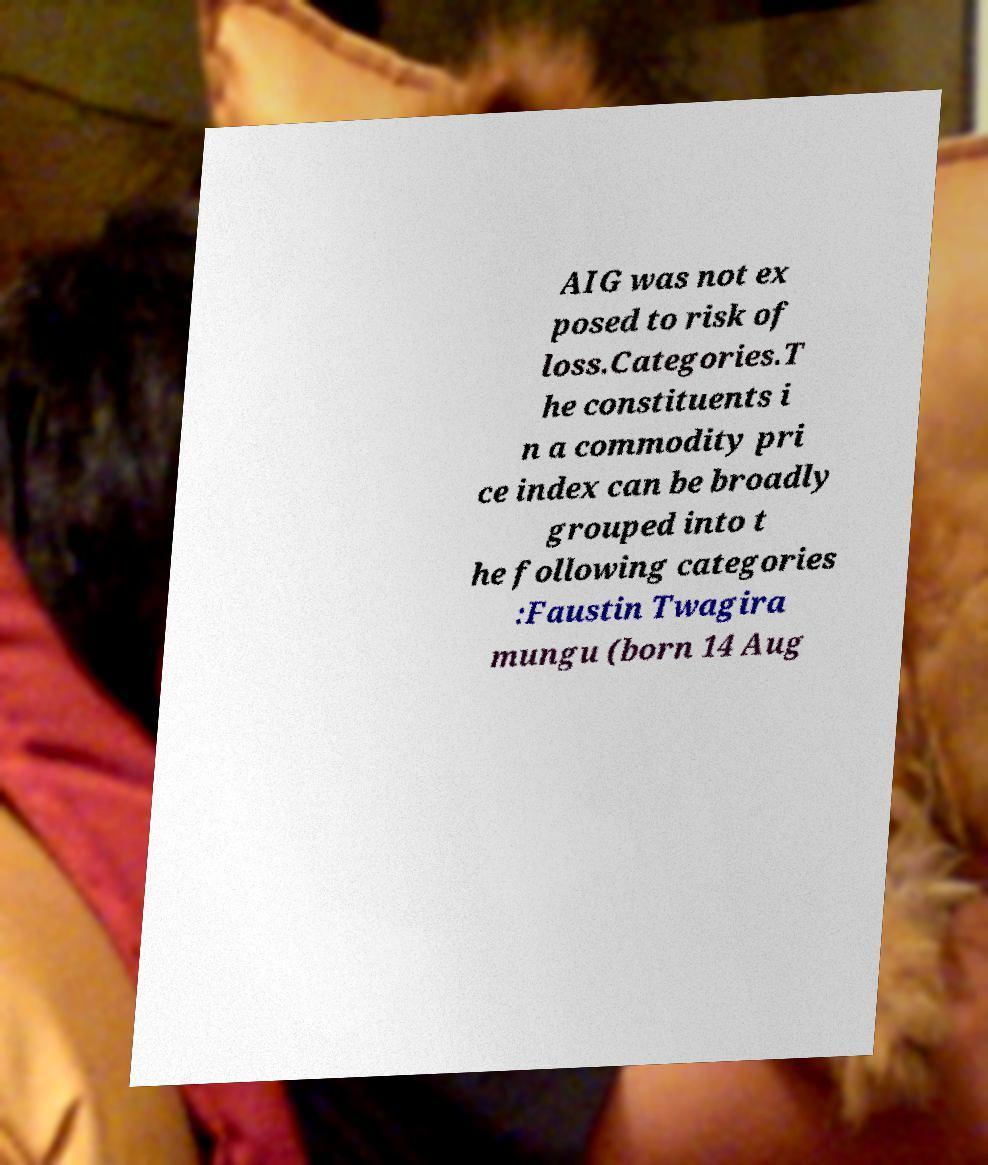Please identify and transcribe the text found in this image. AIG was not ex posed to risk of loss.Categories.T he constituents i n a commodity pri ce index can be broadly grouped into t he following categories :Faustin Twagira mungu (born 14 Aug 